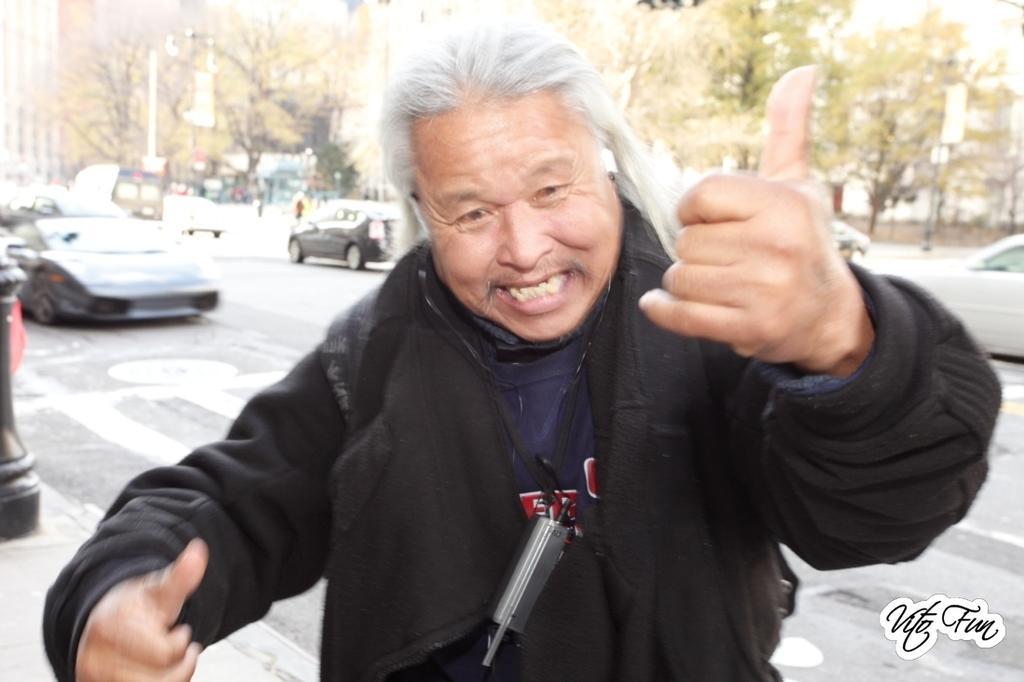How would you summarize this image in a sentence or two? In this picture I can see a watermark on the image. Here I can see a man is standing and wearing black color dress. In the background I can see vehicles on the road and trees. On the right side I can see a black color object. 